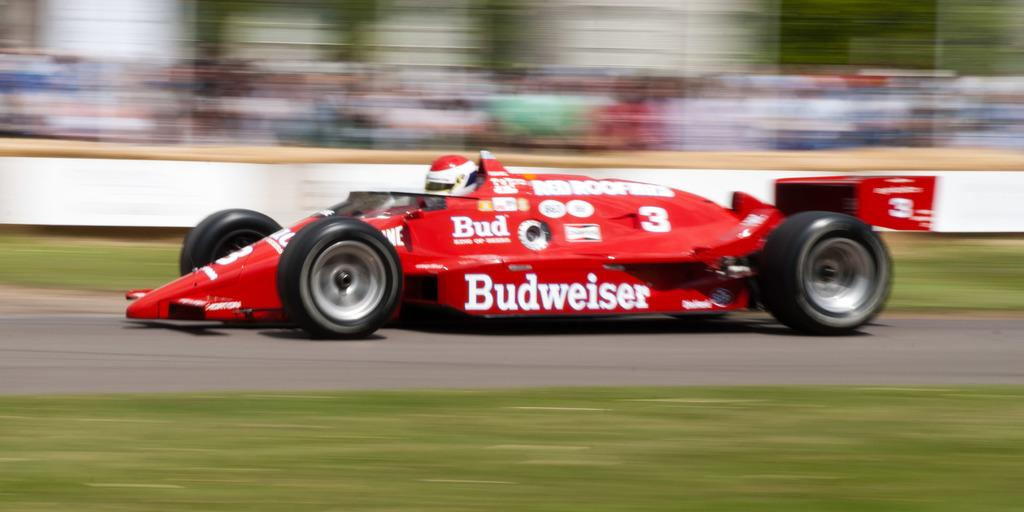What is the main subject in the center of the image? There is a vehicle in the center of the image. What can be seen at the bottom of the image? There is a walkway at the bottom of the image. What type of vegetation is present in the image? Grass is present in the image. How would you describe the background of the image? The background of the image is blurry. Where is the office located in the image? There is no office present in the image. What part of the vehicle is made of underwear? There is no underwear present in the image, and the vehicle is not made of underwear. 